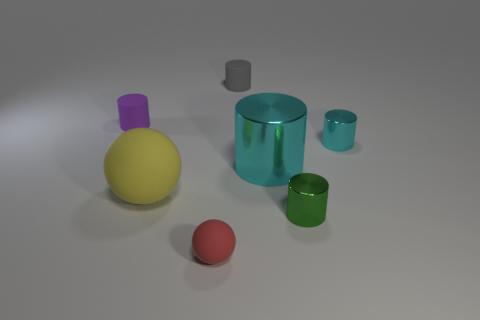Subtract all purple rubber cylinders. How many cylinders are left? 4 Subtract all purple cylinders. How many cylinders are left? 4 Subtract all brown cylinders. Subtract all blue spheres. How many cylinders are left? 5 Add 2 tiny yellow balls. How many objects exist? 9 Subtract all balls. How many objects are left? 5 Subtract all red spheres. Subtract all big red shiny cylinders. How many objects are left? 6 Add 3 rubber objects. How many rubber objects are left? 7 Add 6 large cyan things. How many large cyan things exist? 7 Subtract 0 yellow cylinders. How many objects are left? 7 